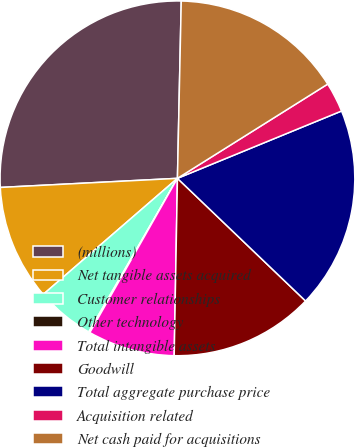<chart> <loc_0><loc_0><loc_500><loc_500><pie_chart><fcel>(millions)<fcel>Net tangible assets acquired<fcel>Customer relationships<fcel>Other technology<fcel>Total intangible assets<fcel>Goodwill<fcel>Total aggregate purchase price<fcel>Acquisition related<fcel>Net cash paid for acquisitions<nl><fcel>26.16%<fcel>10.53%<fcel>5.32%<fcel>0.11%<fcel>7.93%<fcel>13.14%<fcel>18.35%<fcel>2.72%<fcel>15.74%<nl></chart> 